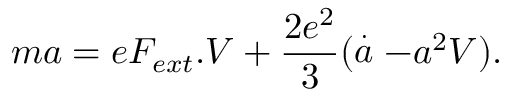<formula> <loc_0><loc_0><loc_500><loc_500>m a = e F _ { e x t } . V + \frac { 2 e ^ { 2 } } { 3 } ( \stackrel { . } { a } - a ^ { 2 } V ) .</formula> 